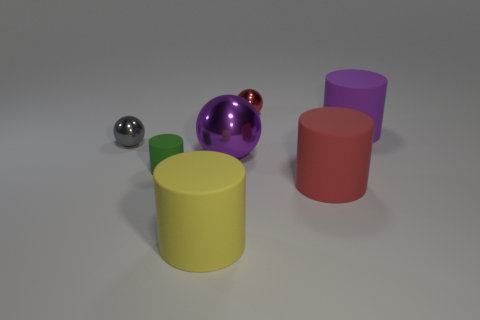What number of objects are shiny balls that are right of the big purple metal object or large purple shiny cylinders?
Give a very brief answer. 1. Is the purple ball made of the same material as the small ball that is on the right side of the yellow thing?
Offer a very short reply. Yes. What number of other things are the same shape as the big red thing?
Your answer should be compact. 3. What number of objects are matte things to the left of the purple ball or objects that are left of the big purple matte cylinder?
Your answer should be very brief. 6. What number of other things are there of the same color as the tiny rubber cylinder?
Provide a short and direct response. 0. Are there fewer matte things to the right of the small red shiny thing than objects right of the tiny green matte thing?
Ensure brevity in your answer.  Yes. How many big purple matte cylinders are there?
Keep it short and to the point. 1. There is a red thing that is the same shape as the tiny gray thing; what is it made of?
Keep it short and to the point. Metal. Are there fewer tiny red metallic objects that are to the right of the purple rubber cylinder than tiny purple matte things?
Provide a short and direct response. No. There is a rubber thing that is behind the big purple sphere; is its shape the same as the yellow matte object?
Offer a very short reply. Yes. 